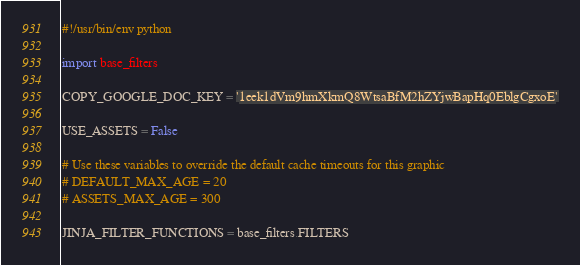<code> <loc_0><loc_0><loc_500><loc_500><_Python_>#!/usr/bin/env python

import base_filters

COPY_GOOGLE_DOC_KEY = '1eek1dVm9hmXkmQ8WtsaBfM2hZYjwBapHq0EblgCgxoE'

USE_ASSETS = False

# Use these variables to override the default cache timeouts for this graphic
# DEFAULT_MAX_AGE = 20
# ASSETS_MAX_AGE = 300

JINJA_FILTER_FUNCTIONS = base_filters.FILTERS
</code> 